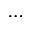<formula> <loc_0><loc_0><loc_500><loc_500>\cdots</formula> 